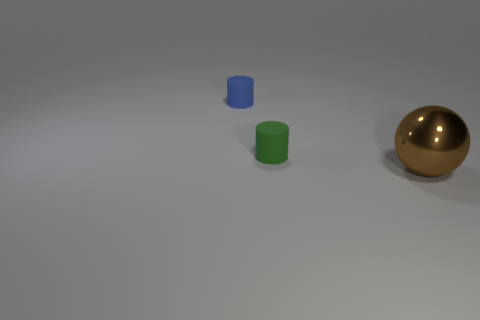How many tiny cyan rubber things are there?
Give a very brief answer. 0. What is the size of the other rubber thing that is the same shape as the tiny blue thing?
Offer a very short reply. Small. There is a tiny matte object in front of the blue matte cylinder; does it have the same shape as the blue matte object?
Your answer should be very brief. Yes. What is the color of the matte thing that is in front of the blue cylinder?
Your response must be concise. Green. How many other things are the same size as the brown metal object?
Provide a succinct answer. 0. Is there any other thing that is the same shape as the big object?
Provide a succinct answer. No. Is the number of small green cylinders on the left side of the green matte object the same as the number of large brown things?
Offer a very short reply. No. What number of other objects are the same material as the tiny green object?
Keep it short and to the point. 1. What is the color of the other object that is made of the same material as the tiny green thing?
Provide a short and direct response. Blue. Does the large brown thing have the same shape as the tiny green rubber object?
Ensure brevity in your answer.  No. 